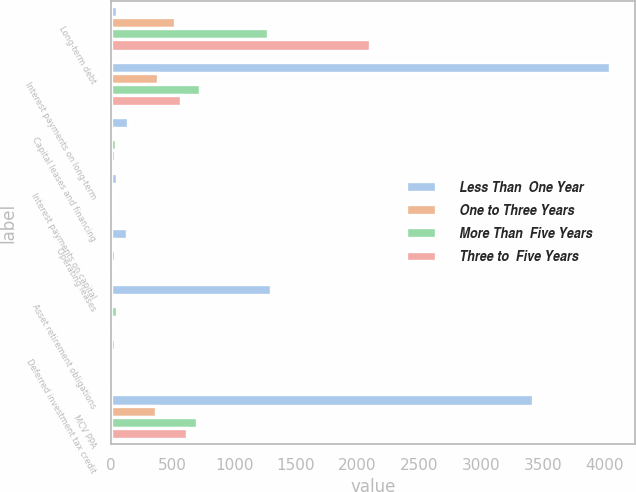Convert chart. <chart><loc_0><loc_0><loc_500><loc_500><stacked_bar_chart><ecel><fcel>Long-term debt<fcel>Interest payments on long-term<fcel>Capital leases and financing<fcel>Interest payments on capital<fcel>Operating leases<fcel>Asset retirement obligations<fcel>Deferred investment tax credit<fcel>MCV PPA<nl><fcel>Less Than  One Year<fcel>51<fcel>4045<fcel>144<fcel>54<fcel>129<fcel>1298<fcel>37<fcel>3425<nl><fcel>One to Three Years<fcel>519<fcel>380<fcel>24<fcel>9<fcel>25<fcel>11<fcel>3<fcel>370<nl><fcel>More Than  Five Years<fcel>1276<fcel>724<fcel>41<fcel>16<fcel>38<fcel>51<fcel>6<fcel>696<nl><fcel>Three to  Five Years<fcel>2100<fcel>570<fcel>38<fcel>14<fcel>26<fcel>20<fcel>5<fcel>617<nl></chart> 